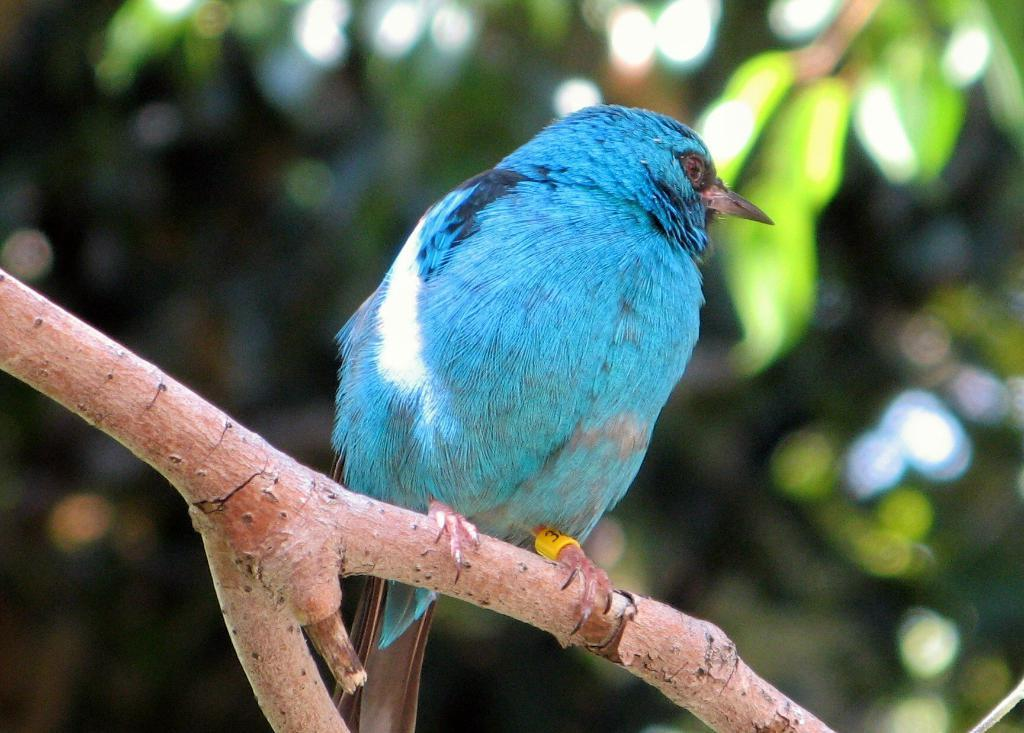What type of animal can be seen in the image? There is a bird in the image. Where is the bird located in the image? The bird is on the branch of a tree. What action is the bird performing in the image? The image does not show the bird performing any specific action; it is simply perched on the branch of a tree. Is the bird stretching its wings in the image? There is no indication in the image that the bird is stretching its wings. 